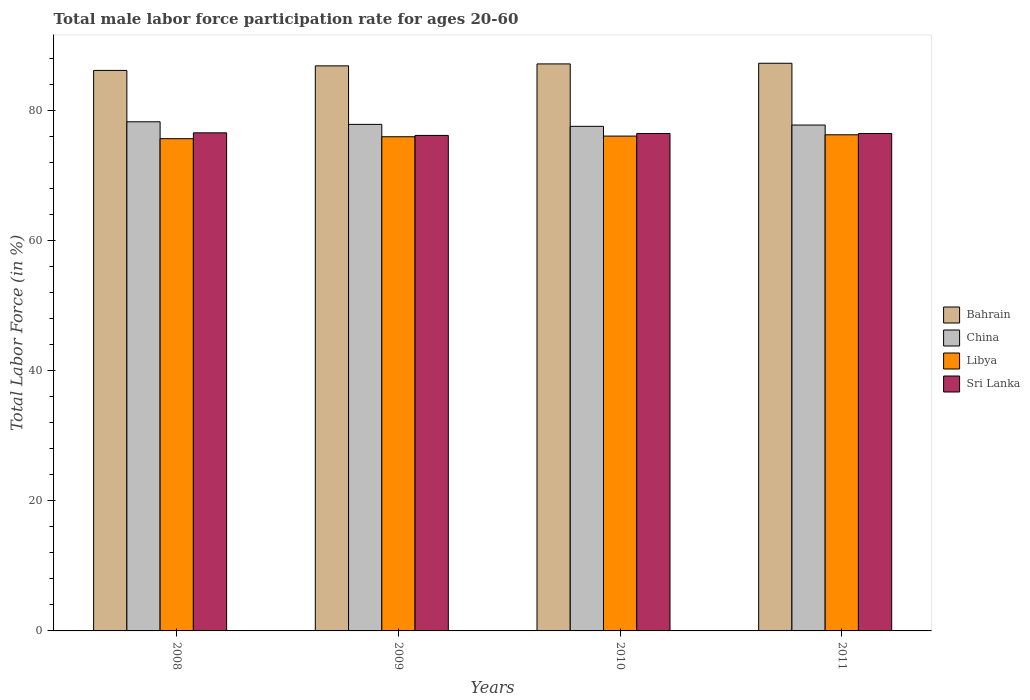How many different coloured bars are there?
Keep it short and to the point. 4. Are the number of bars per tick equal to the number of legend labels?
Keep it short and to the point. Yes. Are the number of bars on each tick of the X-axis equal?
Your answer should be compact. Yes. How many bars are there on the 3rd tick from the left?
Your answer should be compact. 4. How many bars are there on the 4th tick from the right?
Offer a terse response. 4. What is the label of the 4th group of bars from the left?
Ensure brevity in your answer.  2011. In how many cases, is the number of bars for a given year not equal to the number of legend labels?
Give a very brief answer. 0. What is the male labor force participation rate in Bahrain in 2010?
Give a very brief answer. 87.2. Across all years, what is the maximum male labor force participation rate in Libya?
Ensure brevity in your answer.  76.3. Across all years, what is the minimum male labor force participation rate in Bahrain?
Keep it short and to the point. 86.2. In which year was the male labor force participation rate in Libya minimum?
Your answer should be very brief. 2008. What is the total male labor force participation rate in China in the graph?
Offer a very short reply. 311.6. What is the difference between the male labor force participation rate in Libya in 2008 and that in 2009?
Keep it short and to the point. -0.3. What is the difference between the male labor force participation rate in Sri Lanka in 2008 and the male labor force participation rate in Libya in 2009?
Your answer should be very brief. 0.6. What is the average male labor force participation rate in Sri Lanka per year?
Provide a succinct answer. 76.45. In the year 2009, what is the difference between the male labor force participation rate in Libya and male labor force participation rate in Bahrain?
Ensure brevity in your answer.  -10.9. In how many years, is the male labor force participation rate in China greater than 36 %?
Provide a short and direct response. 4. What is the ratio of the male labor force participation rate in Sri Lanka in 2008 to that in 2010?
Make the answer very short. 1. What is the difference between the highest and the second highest male labor force participation rate in Sri Lanka?
Give a very brief answer. 0.1. What is the difference between the highest and the lowest male labor force participation rate in Bahrain?
Provide a short and direct response. 1.1. In how many years, is the male labor force participation rate in Bahrain greater than the average male labor force participation rate in Bahrain taken over all years?
Offer a very short reply. 3. Is it the case that in every year, the sum of the male labor force participation rate in China and male labor force participation rate in Sri Lanka is greater than the sum of male labor force participation rate in Libya and male labor force participation rate in Bahrain?
Keep it short and to the point. No. What does the 3rd bar from the left in 2011 represents?
Make the answer very short. Libya. What does the 2nd bar from the right in 2008 represents?
Your response must be concise. Libya. Is it the case that in every year, the sum of the male labor force participation rate in Sri Lanka and male labor force participation rate in China is greater than the male labor force participation rate in Bahrain?
Ensure brevity in your answer.  Yes. How many bars are there?
Your answer should be very brief. 16. Are all the bars in the graph horizontal?
Give a very brief answer. No. What is the difference between two consecutive major ticks on the Y-axis?
Offer a very short reply. 20. Does the graph contain grids?
Provide a short and direct response. No. Where does the legend appear in the graph?
Provide a short and direct response. Center right. How many legend labels are there?
Offer a very short reply. 4. How are the legend labels stacked?
Give a very brief answer. Vertical. What is the title of the graph?
Give a very brief answer. Total male labor force participation rate for ages 20-60. What is the label or title of the X-axis?
Keep it short and to the point. Years. What is the label or title of the Y-axis?
Offer a terse response. Total Labor Force (in %). What is the Total Labor Force (in %) of Bahrain in 2008?
Provide a short and direct response. 86.2. What is the Total Labor Force (in %) of China in 2008?
Keep it short and to the point. 78.3. What is the Total Labor Force (in %) in Libya in 2008?
Offer a very short reply. 75.7. What is the Total Labor Force (in %) of Sri Lanka in 2008?
Offer a terse response. 76.6. What is the Total Labor Force (in %) in Bahrain in 2009?
Make the answer very short. 86.9. What is the Total Labor Force (in %) in China in 2009?
Ensure brevity in your answer.  77.9. What is the Total Labor Force (in %) of Libya in 2009?
Your response must be concise. 76. What is the Total Labor Force (in %) in Sri Lanka in 2009?
Keep it short and to the point. 76.2. What is the Total Labor Force (in %) of Bahrain in 2010?
Make the answer very short. 87.2. What is the Total Labor Force (in %) in China in 2010?
Offer a terse response. 77.6. What is the Total Labor Force (in %) of Libya in 2010?
Provide a short and direct response. 76.1. What is the Total Labor Force (in %) of Sri Lanka in 2010?
Give a very brief answer. 76.5. What is the Total Labor Force (in %) in Bahrain in 2011?
Your response must be concise. 87.3. What is the Total Labor Force (in %) in China in 2011?
Provide a succinct answer. 77.8. What is the Total Labor Force (in %) of Libya in 2011?
Offer a very short reply. 76.3. What is the Total Labor Force (in %) of Sri Lanka in 2011?
Offer a very short reply. 76.5. Across all years, what is the maximum Total Labor Force (in %) of Bahrain?
Offer a terse response. 87.3. Across all years, what is the maximum Total Labor Force (in %) in China?
Keep it short and to the point. 78.3. Across all years, what is the maximum Total Labor Force (in %) of Libya?
Provide a succinct answer. 76.3. Across all years, what is the maximum Total Labor Force (in %) in Sri Lanka?
Your answer should be compact. 76.6. Across all years, what is the minimum Total Labor Force (in %) in Bahrain?
Your response must be concise. 86.2. Across all years, what is the minimum Total Labor Force (in %) of China?
Make the answer very short. 77.6. Across all years, what is the minimum Total Labor Force (in %) in Libya?
Provide a succinct answer. 75.7. Across all years, what is the minimum Total Labor Force (in %) in Sri Lanka?
Your answer should be compact. 76.2. What is the total Total Labor Force (in %) in Bahrain in the graph?
Give a very brief answer. 347.6. What is the total Total Labor Force (in %) of China in the graph?
Provide a short and direct response. 311.6. What is the total Total Labor Force (in %) of Libya in the graph?
Keep it short and to the point. 304.1. What is the total Total Labor Force (in %) of Sri Lanka in the graph?
Keep it short and to the point. 305.8. What is the difference between the Total Labor Force (in %) in Bahrain in 2008 and that in 2009?
Ensure brevity in your answer.  -0.7. What is the difference between the Total Labor Force (in %) of Libya in 2008 and that in 2009?
Your answer should be very brief. -0.3. What is the difference between the Total Labor Force (in %) of Sri Lanka in 2008 and that in 2009?
Provide a short and direct response. 0.4. What is the difference between the Total Labor Force (in %) of Bahrain in 2008 and that in 2010?
Give a very brief answer. -1. What is the difference between the Total Labor Force (in %) in Sri Lanka in 2008 and that in 2010?
Offer a very short reply. 0.1. What is the difference between the Total Labor Force (in %) of Bahrain in 2008 and that in 2011?
Keep it short and to the point. -1.1. What is the difference between the Total Labor Force (in %) in Bahrain in 2009 and that in 2010?
Ensure brevity in your answer.  -0.3. What is the difference between the Total Labor Force (in %) of Bahrain in 2009 and that in 2011?
Offer a very short reply. -0.4. What is the difference between the Total Labor Force (in %) in China in 2009 and that in 2011?
Provide a short and direct response. 0.1. What is the difference between the Total Labor Force (in %) of Sri Lanka in 2009 and that in 2011?
Ensure brevity in your answer.  -0.3. What is the difference between the Total Labor Force (in %) in Bahrain in 2008 and the Total Labor Force (in %) in Libya in 2009?
Provide a short and direct response. 10.2. What is the difference between the Total Labor Force (in %) of China in 2008 and the Total Labor Force (in %) of Libya in 2009?
Your response must be concise. 2.3. What is the difference between the Total Labor Force (in %) in China in 2008 and the Total Labor Force (in %) in Sri Lanka in 2009?
Offer a very short reply. 2.1. What is the difference between the Total Labor Force (in %) of Libya in 2008 and the Total Labor Force (in %) of Sri Lanka in 2009?
Provide a short and direct response. -0.5. What is the difference between the Total Labor Force (in %) in Bahrain in 2008 and the Total Labor Force (in %) in China in 2010?
Provide a short and direct response. 8.6. What is the difference between the Total Labor Force (in %) of Bahrain in 2008 and the Total Labor Force (in %) of Libya in 2010?
Provide a succinct answer. 10.1. What is the difference between the Total Labor Force (in %) of China in 2008 and the Total Labor Force (in %) of Sri Lanka in 2010?
Give a very brief answer. 1.8. What is the difference between the Total Labor Force (in %) in Bahrain in 2008 and the Total Labor Force (in %) in Libya in 2011?
Keep it short and to the point. 9.9. What is the difference between the Total Labor Force (in %) in China in 2008 and the Total Labor Force (in %) in Sri Lanka in 2011?
Provide a succinct answer. 1.8. What is the difference between the Total Labor Force (in %) in Libya in 2008 and the Total Labor Force (in %) in Sri Lanka in 2011?
Your answer should be very brief. -0.8. What is the difference between the Total Labor Force (in %) in Bahrain in 2009 and the Total Labor Force (in %) in China in 2010?
Provide a short and direct response. 9.3. What is the difference between the Total Labor Force (in %) of China in 2009 and the Total Labor Force (in %) of Libya in 2010?
Provide a succinct answer. 1.8. What is the difference between the Total Labor Force (in %) of Libya in 2009 and the Total Labor Force (in %) of Sri Lanka in 2010?
Keep it short and to the point. -0.5. What is the difference between the Total Labor Force (in %) of China in 2009 and the Total Labor Force (in %) of Libya in 2011?
Your response must be concise. 1.6. What is the difference between the Total Labor Force (in %) of China in 2009 and the Total Labor Force (in %) of Sri Lanka in 2011?
Ensure brevity in your answer.  1.4. What is the difference between the Total Labor Force (in %) of Libya in 2009 and the Total Labor Force (in %) of Sri Lanka in 2011?
Keep it short and to the point. -0.5. What is the difference between the Total Labor Force (in %) in Bahrain in 2010 and the Total Labor Force (in %) in China in 2011?
Your response must be concise. 9.4. What is the difference between the Total Labor Force (in %) in Bahrain in 2010 and the Total Labor Force (in %) in Libya in 2011?
Offer a very short reply. 10.9. What is the difference between the Total Labor Force (in %) of China in 2010 and the Total Labor Force (in %) of Sri Lanka in 2011?
Provide a succinct answer. 1.1. What is the difference between the Total Labor Force (in %) of Libya in 2010 and the Total Labor Force (in %) of Sri Lanka in 2011?
Provide a short and direct response. -0.4. What is the average Total Labor Force (in %) in Bahrain per year?
Provide a succinct answer. 86.9. What is the average Total Labor Force (in %) of China per year?
Make the answer very short. 77.9. What is the average Total Labor Force (in %) in Libya per year?
Ensure brevity in your answer.  76.03. What is the average Total Labor Force (in %) in Sri Lanka per year?
Give a very brief answer. 76.45. In the year 2008, what is the difference between the Total Labor Force (in %) in Bahrain and Total Labor Force (in %) in China?
Your response must be concise. 7.9. In the year 2008, what is the difference between the Total Labor Force (in %) in Libya and Total Labor Force (in %) in Sri Lanka?
Offer a very short reply. -0.9. In the year 2009, what is the difference between the Total Labor Force (in %) in Bahrain and Total Labor Force (in %) in Sri Lanka?
Your answer should be very brief. 10.7. In the year 2009, what is the difference between the Total Labor Force (in %) in China and Total Labor Force (in %) in Libya?
Provide a short and direct response. 1.9. In the year 2010, what is the difference between the Total Labor Force (in %) of Bahrain and Total Labor Force (in %) of Libya?
Your response must be concise. 11.1. In the year 2010, what is the difference between the Total Labor Force (in %) of China and Total Labor Force (in %) of Libya?
Give a very brief answer. 1.5. In the year 2010, what is the difference between the Total Labor Force (in %) of China and Total Labor Force (in %) of Sri Lanka?
Give a very brief answer. 1.1. In the year 2010, what is the difference between the Total Labor Force (in %) in Libya and Total Labor Force (in %) in Sri Lanka?
Provide a succinct answer. -0.4. In the year 2011, what is the difference between the Total Labor Force (in %) in Bahrain and Total Labor Force (in %) in Libya?
Provide a succinct answer. 11. In the year 2011, what is the difference between the Total Labor Force (in %) in Bahrain and Total Labor Force (in %) in Sri Lanka?
Offer a very short reply. 10.8. In the year 2011, what is the difference between the Total Labor Force (in %) of Libya and Total Labor Force (in %) of Sri Lanka?
Provide a succinct answer. -0.2. What is the ratio of the Total Labor Force (in %) in Bahrain in 2008 to that in 2010?
Offer a very short reply. 0.99. What is the ratio of the Total Labor Force (in %) in China in 2008 to that in 2010?
Your response must be concise. 1.01. What is the ratio of the Total Labor Force (in %) in Libya in 2008 to that in 2010?
Your answer should be compact. 0.99. What is the ratio of the Total Labor Force (in %) in Bahrain in 2008 to that in 2011?
Your answer should be compact. 0.99. What is the ratio of the Total Labor Force (in %) in China in 2008 to that in 2011?
Offer a very short reply. 1.01. What is the ratio of the Total Labor Force (in %) of Sri Lanka in 2008 to that in 2011?
Offer a terse response. 1. What is the ratio of the Total Labor Force (in %) in Bahrain in 2009 to that in 2010?
Provide a succinct answer. 1. What is the ratio of the Total Labor Force (in %) in Libya in 2009 to that in 2010?
Provide a short and direct response. 1. What is the ratio of the Total Labor Force (in %) in Sri Lanka in 2009 to that in 2010?
Offer a terse response. 1. What is the ratio of the Total Labor Force (in %) in Bahrain in 2009 to that in 2011?
Keep it short and to the point. 1. What is the ratio of the Total Labor Force (in %) in China in 2009 to that in 2011?
Keep it short and to the point. 1. What is the ratio of the Total Labor Force (in %) in Libya in 2010 to that in 2011?
Provide a succinct answer. 1. What is the ratio of the Total Labor Force (in %) in Sri Lanka in 2010 to that in 2011?
Ensure brevity in your answer.  1. What is the difference between the highest and the second highest Total Labor Force (in %) in Sri Lanka?
Your answer should be very brief. 0.1. What is the difference between the highest and the lowest Total Labor Force (in %) in Bahrain?
Ensure brevity in your answer.  1.1. What is the difference between the highest and the lowest Total Labor Force (in %) of China?
Give a very brief answer. 0.7. What is the difference between the highest and the lowest Total Labor Force (in %) in Libya?
Make the answer very short. 0.6. What is the difference between the highest and the lowest Total Labor Force (in %) of Sri Lanka?
Your response must be concise. 0.4. 